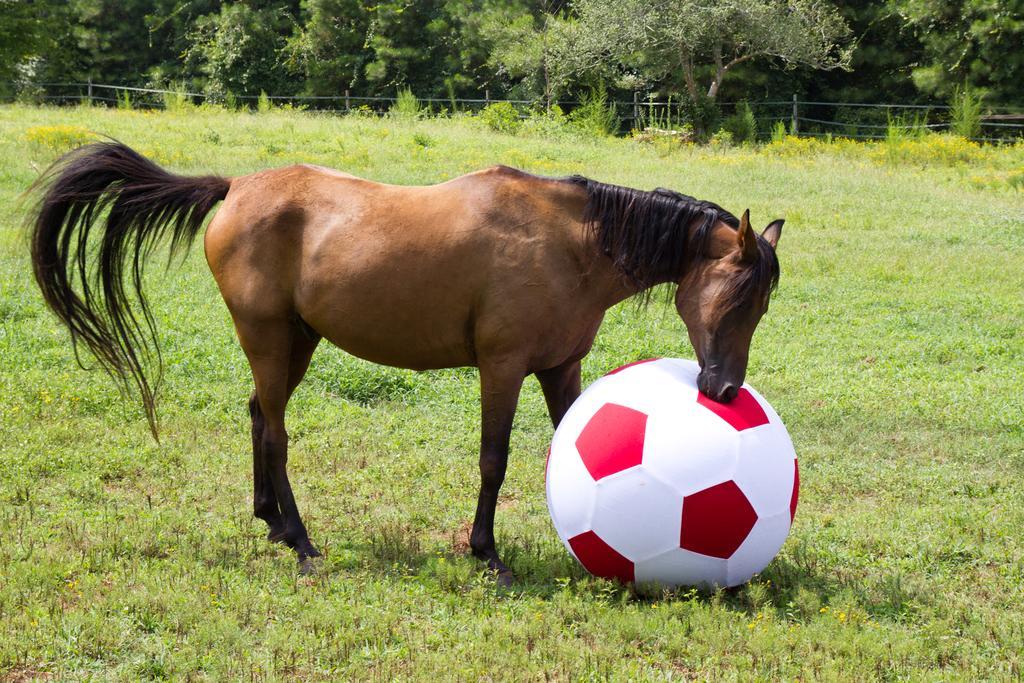Describe this image in one or two sentences. In the center of the image horse and ball are there. In the background of the image we can see some plants, trees, fencing are there. At the bottom of the image ground is there. 